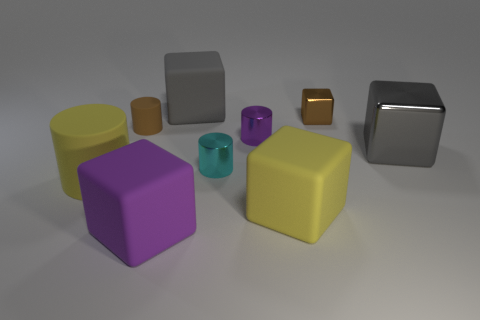There is a yellow thing that is the same material as the big cylinder; what is its size?
Offer a very short reply. Large. Is there another object that has the same shape as the large gray shiny thing?
Provide a short and direct response. Yes. How many things are blocks that are left of the gray metal object or small purple metallic objects?
Give a very brief answer. 5. What size is the other thing that is the same color as the big shiny object?
Your answer should be very brief. Large. Does the big matte block that is behind the small purple object have the same color as the large metallic cube to the right of the purple matte cube?
Offer a very short reply. Yes. The yellow block has what size?
Your response must be concise. Large. How many large objects are either purple metallic cubes or gray blocks?
Offer a terse response. 2. There is a metallic cube that is the same size as the cyan cylinder; what color is it?
Provide a succinct answer. Brown. What number of other things are the same shape as the brown shiny thing?
Your answer should be compact. 4. Is there a gray cylinder made of the same material as the cyan cylinder?
Your answer should be compact. No. 